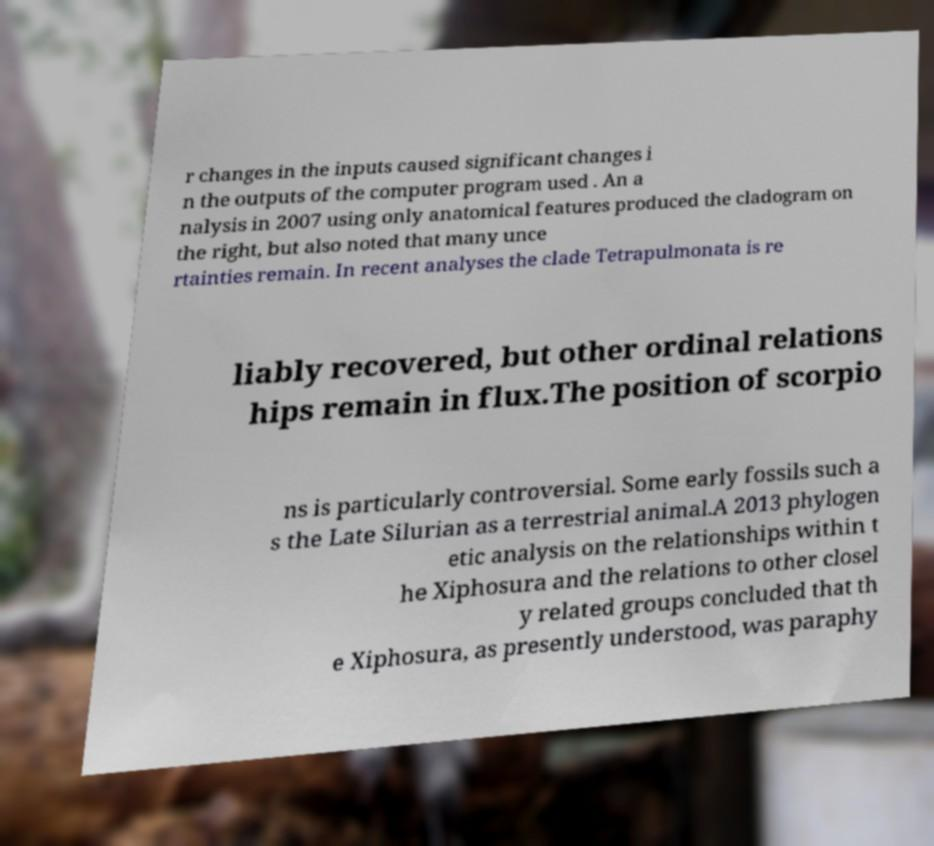There's text embedded in this image that I need extracted. Can you transcribe it verbatim? r changes in the inputs caused significant changes i n the outputs of the computer program used . An a nalysis in 2007 using only anatomical features produced the cladogram on the right, but also noted that many unce rtainties remain. In recent analyses the clade Tetrapulmonata is re liably recovered, but other ordinal relations hips remain in flux.The position of scorpio ns is particularly controversial. Some early fossils such a s the Late Silurian as a terrestrial animal.A 2013 phylogen etic analysis on the relationships within t he Xiphosura and the relations to other closel y related groups concluded that th e Xiphosura, as presently understood, was paraphy 